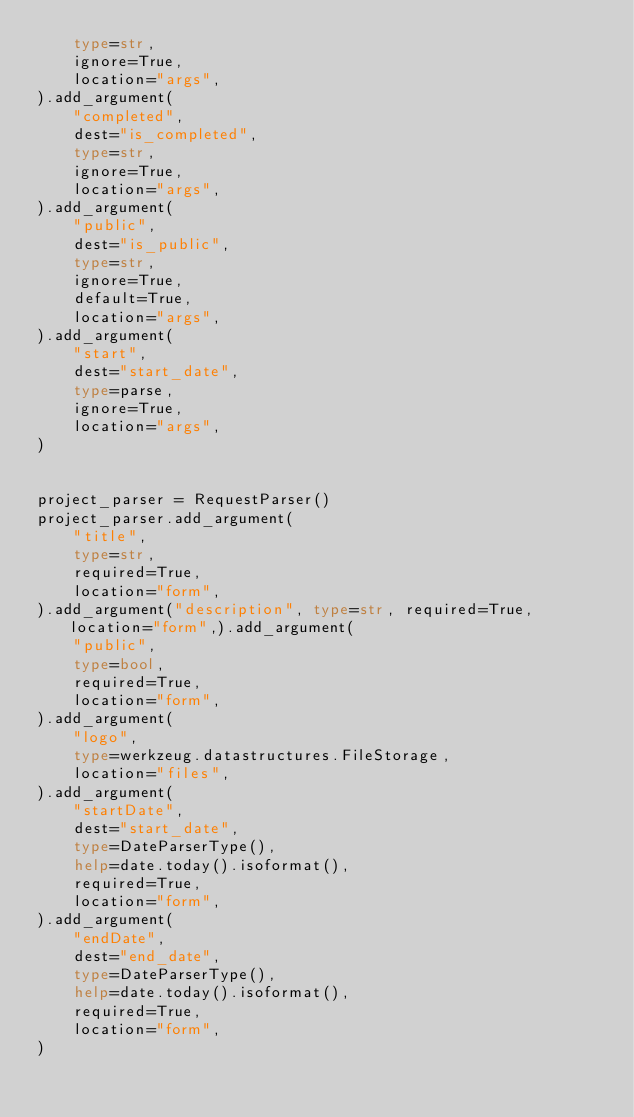<code> <loc_0><loc_0><loc_500><loc_500><_Python_>    type=str,
    ignore=True,
    location="args",
).add_argument(
    "completed",
    dest="is_completed",
    type=str,
    ignore=True,
    location="args",
).add_argument(
    "public",
    dest="is_public",
    type=str,
    ignore=True,
    default=True,
    location="args",
).add_argument(
    "start",
    dest="start_date",
    type=parse,
    ignore=True,
    location="args",
)


project_parser = RequestParser()
project_parser.add_argument(
    "title",
    type=str,
    required=True,
    location="form",
).add_argument("description", type=str, required=True, location="form",).add_argument(
    "public",
    type=bool,
    required=True,
    location="form",
).add_argument(
    "logo",
    type=werkzeug.datastructures.FileStorage,
    location="files",
).add_argument(
    "startDate",
    dest="start_date",
    type=DateParserType(),
    help=date.today().isoformat(),
    required=True,
    location="form",
).add_argument(
    "endDate",
    dest="end_date",
    type=DateParserType(),
    help=date.today().isoformat(),
    required=True,
    location="form",
)
</code> 